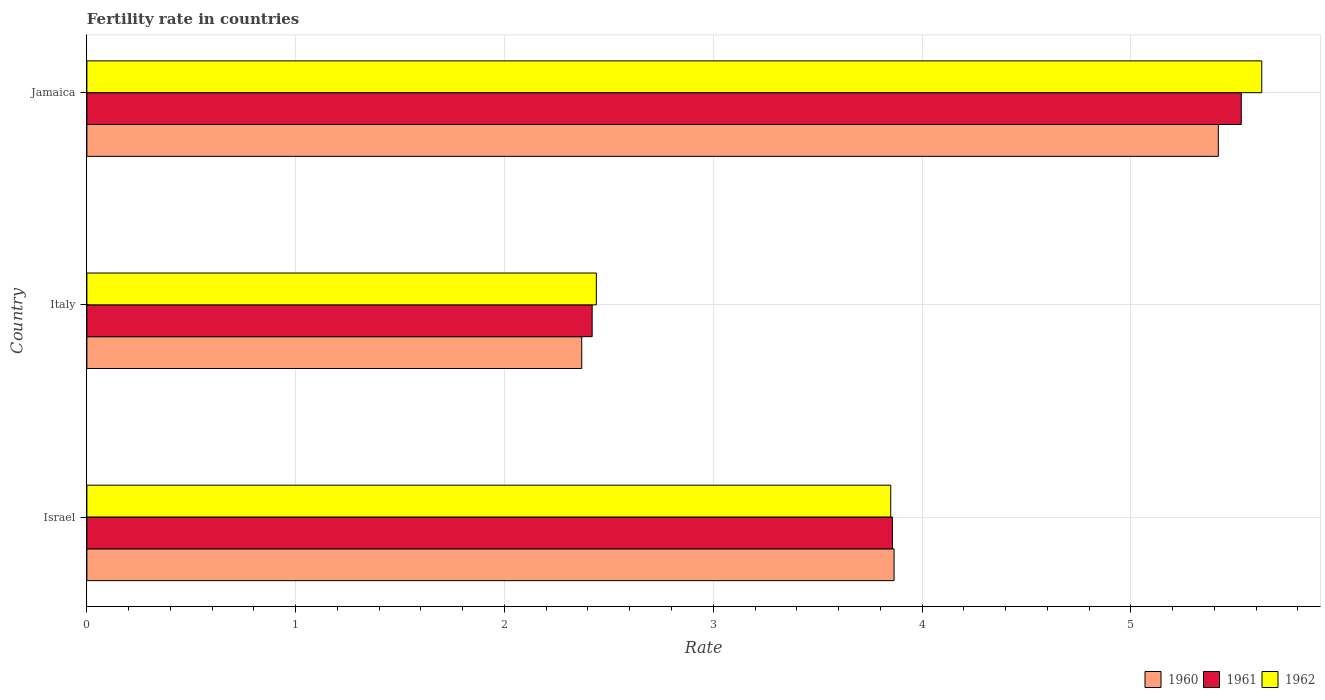How many groups of bars are there?
Provide a short and direct response. 3. Are the number of bars per tick equal to the number of legend labels?
Give a very brief answer. Yes. How many bars are there on the 3rd tick from the top?
Your answer should be compact. 3. In how many cases, is the number of bars for a given country not equal to the number of legend labels?
Make the answer very short. 0. What is the fertility rate in 1960 in Italy?
Your answer should be compact. 2.37. Across all countries, what is the maximum fertility rate in 1962?
Give a very brief answer. 5.63. Across all countries, what is the minimum fertility rate in 1960?
Keep it short and to the point. 2.37. In which country was the fertility rate in 1960 maximum?
Your answer should be compact. Jamaica. What is the total fertility rate in 1962 in the graph?
Provide a succinct answer. 11.92. What is the difference between the fertility rate in 1962 in Israel and that in Jamaica?
Your answer should be very brief. -1.78. What is the difference between the fertility rate in 1961 in Israel and the fertility rate in 1960 in Jamaica?
Give a very brief answer. -1.56. What is the average fertility rate in 1960 per country?
Keep it short and to the point. 3.89. What is the difference between the fertility rate in 1962 and fertility rate in 1960 in Jamaica?
Ensure brevity in your answer.  0.21. In how many countries, is the fertility rate in 1961 greater than 5.2 ?
Give a very brief answer. 1. What is the ratio of the fertility rate in 1961 in Israel to that in Jamaica?
Provide a succinct answer. 0.7. What is the difference between the highest and the second highest fertility rate in 1960?
Offer a very short reply. 1.55. What is the difference between the highest and the lowest fertility rate in 1961?
Offer a terse response. 3.11. Is it the case that in every country, the sum of the fertility rate in 1960 and fertility rate in 1961 is greater than the fertility rate in 1962?
Keep it short and to the point. Yes. What is the difference between two consecutive major ticks on the X-axis?
Offer a terse response. 1. Are the values on the major ticks of X-axis written in scientific E-notation?
Ensure brevity in your answer.  No. Where does the legend appear in the graph?
Give a very brief answer. Bottom right. How many legend labels are there?
Your answer should be compact. 3. What is the title of the graph?
Keep it short and to the point. Fertility rate in countries. Does "1990" appear as one of the legend labels in the graph?
Provide a succinct answer. No. What is the label or title of the X-axis?
Your answer should be compact. Rate. What is the Rate in 1960 in Israel?
Provide a succinct answer. 3.87. What is the Rate in 1961 in Israel?
Offer a terse response. 3.86. What is the Rate in 1962 in Israel?
Your answer should be very brief. 3.85. What is the Rate in 1960 in Italy?
Offer a terse response. 2.37. What is the Rate of 1961 in Italy?
Make the answer very short. 2.42. What is the Rate of 1962 in Italy?
Keep it short and to the point. 2.44. What is the Rate of 1960 in Jamaica?
Your response must be concise. 5.42. What is the Rate of 1961 in Jamaica?
Ensure brevity in your answer.  5.53. What is the Rate in 1962 in Jamaica?
Keep it short and to the point. 5.63. Across all countries, what is the maximum Rate of 1960?
Ensure brevity in your answer.  5.42. Across all countries, what is the maximum Rate of 1961?
Your response must be concise. 5.53. Across all countries, what is the maximum Rate in 1962?
Provide a succinct answer. 5.63. Across all countries, what is the minimum Rate of 1960?
Your response must be concise. 2.37. Across all countries, what is the minimum Rate in 1961?
Keep it short and to the point. 2.42. Across all countries, what is the minimum Rate in 1962?
Keep it short and to the point. 2.44. What is the total Rate in 1960 in the graph?
Keep it short and to the point. 11.65. What is the total Rate in 1961 in the graph?
Give a very brief answer. 11.81. What is the total Rate in 1962 in the graph?
Provide a succinct answer. 11.92. What is the difference between the Rate of 1960 in Israel and that in Italy?
Your answer should be compact. 1.5. What is the difference between the Rate of 1961 in Israel and that in Italy?
Make the answer very short. 1.44. What is the difference between the Rate in 1962 in Israel and that in Italy?
Ensure brevity in your answer.  1.41. What is the difference between the Rate of 1960 in Israel and that in Jamaica?
Keep it short and to the point. -1.55. What is the difference between the Rate of 1961 in Israel and that in Jamaica?
Give a very brief answer. -1.67. What is the difference between the Rate of 1962 in Israel and that in Jamaica?
Make the answer very short. -1.78. What is the difference between the Rate in 1960 in Italy and that in Jamaica?
Your answer should be very brief. -3.05. What is the difference between the Rate of 1961 in Italy and that in Jamaica?
Offer a terse response. -3.11. What is the difference between the Rate of 1962 in Italy and that in Jamaica?
Ensure brevity in your answer.  -3.19. What is the difference between the Rate in 1960 in Israel and the Rate in 1961 in Italy?
Provide a succinct answer. 1.45. What is the difference between the Rate of 1960 in Israel and the Rate of 1962 in Italy?
Make the answer very short. 1.43. What is the difference between the Rate of 1961 in Israel and the Rate of 1962 in Italy?
Give a very brief answer. 1.42. What is the difference between the Rate of 1960 in Israel and the Rate of 1961 in Jamaica?
Offer a very short reply. -1.66. What is the difference between the Rate in 1960 in Israel and the Rate in 1962 in Jamaica?
Your response must be concise. -1.76. What is the difference between the Rate of 1961 in Israel and the Rate of 1962 in Jamaica?
Your answer should be very brief. -1.77. What is the difference between the Rate of 1960 in Italy and the Rate of 1961 in Jamaica?
Ensure brevity in your answer.  -3.16. What is the difference between the Rate in 1960 in Italy and the Rate in 1962 in Jamaica?
Offer a terse response. -3.26. What is the difference between the Rate of 1961 in Italy and the Rate of 1962 in Jamaica?
Your response must be concise. -3.21. What is the average Rate in 1960 per country?
Your response must be concise. 3.88. What is the average Rate of 1961 per country?
Keep it short and to the point. 3.94. What is the average Rate in 1962 per country?
Ensure brevity in your answer.  3.97. What is the difference between the Rate in 1960 and Rate in 1961 in Israel?
Your answer should be compact. 0.01. What is the difference between the Rate of 1960 and Rate of 1962 in Israel?
Offer a terse response. 0.02. What is the difference between the Rate of 1961 and Rate of 1962 in Israel?
Give a very brief answer. 0.01. What is the difference between the Rate in 1960 and Rate in 1962 in Italy?
Offer a terse response. -0.07. What is the difference between the Rate of 1961 and Rate of 1962 in Italy?
Your answer should be very brief. -0.02. What is the difference between the Rate of 1960 and Rate of 1961 in Jamaica?
Offer a very short reply. -0.11. What is the difference between the Rate of 1960 and Rate of 1962 in Jamaica?
Keep it short and to the point. -0.21. What is the difference between the Rate of 1961 and Rate of 1962 in Jamaica?
Provide a short and direct response. -0.1. What is the ratio of the Rate in 1960 in Israel to that in Italy?
Your answer should be compact. 1.63. What is the ratio of the Rate in 1961 in Israel to that in Italy?
Provide a succinct answer. 1.59. What is the ratio of the Rate of 1962 in Israel to that in Italy?
Keep it short and to the point. 1.58. What is the ratio of the Rate of 1960 in Israel to that in Jamaica?
Offer a terse response. 0.71. What is the ratio of the Rate in 1961 in Israel to that in Jamaica?
Offer a terse response. 0.7. What is the ratio of the Rate of 1962 in Israel to that in Jamaica?
Your answer should be compact. 0.68. What is the ratio of the Rate in 1960 in Italy to that in Jamaica?
Offer a terse response. 0.44. What is the ratio of the Rate in 1961 in Italy to that in Jamaica?
Ensure brevity in your answer.  0.44. What is the ratio of the Rate in 1962 in Italy to that in Jamaica?
Your answer should be compact. 0.43. What is the difference between the highest and the second highest Rate in 1960?
Ensure brevity in your answer.  1.55. What is the difference between the highest and the second highest Rate of 1961?
Ensure brevity in your answer.  1.67. What is the difference between the highest and the second highest Rate in 1962?
Keep it short and to the point. 1.78. What is the difference between the highest and the lowest Rate of 1960?
Your answer should be compact. 3.05. What is the difference between the highest and the lowest Rate in 1961?
Provide a succinct answer. 3.11. What is the difference between the highest and the lowest Rate of 1962?
Offer a very short reply. 3.19. 